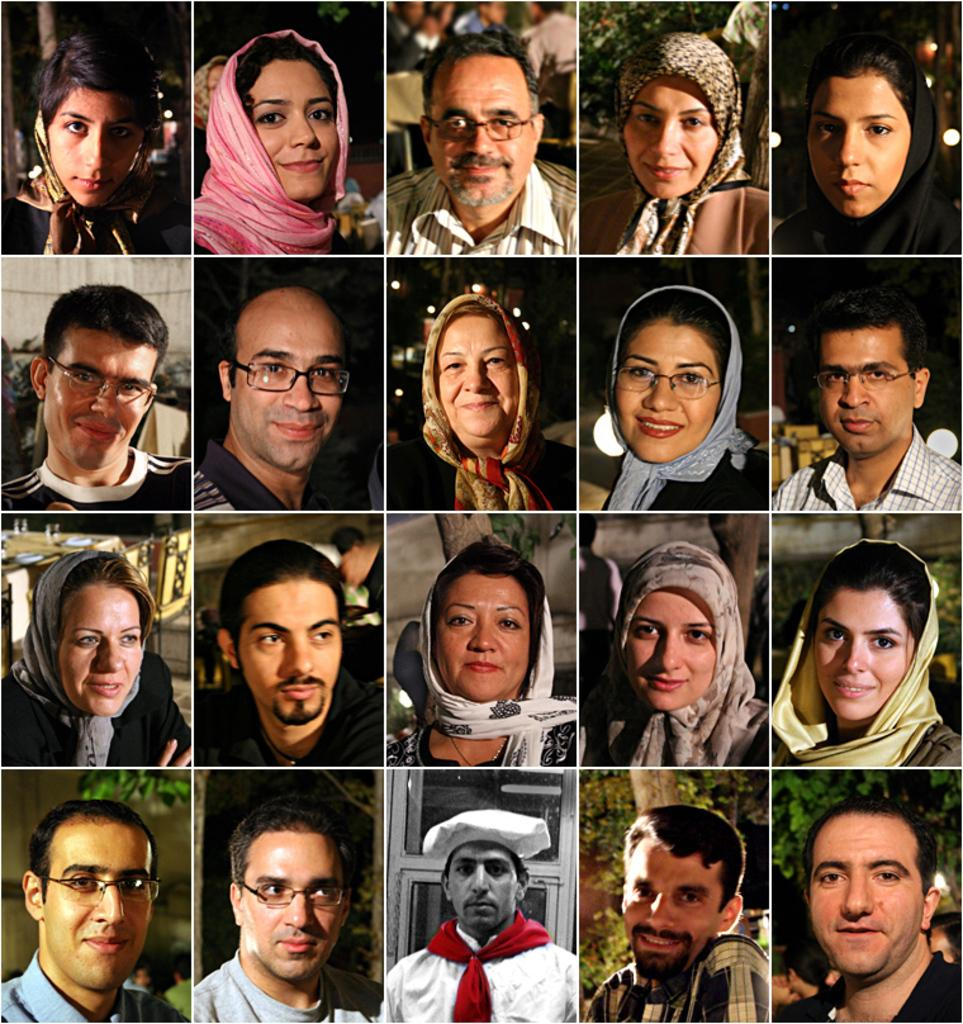What type of artwork is depicted in the image? The image is a collage of many images. Can you describe any specific elements within the collage? There are images of people in the collage. How many layers of cake can be seen in the image? There is no cake present in the image; it is a collage of images, including images of people. What type of lighting fixture is visible in the image? There is no lighting fixture, such as a bulb, present in the image. 